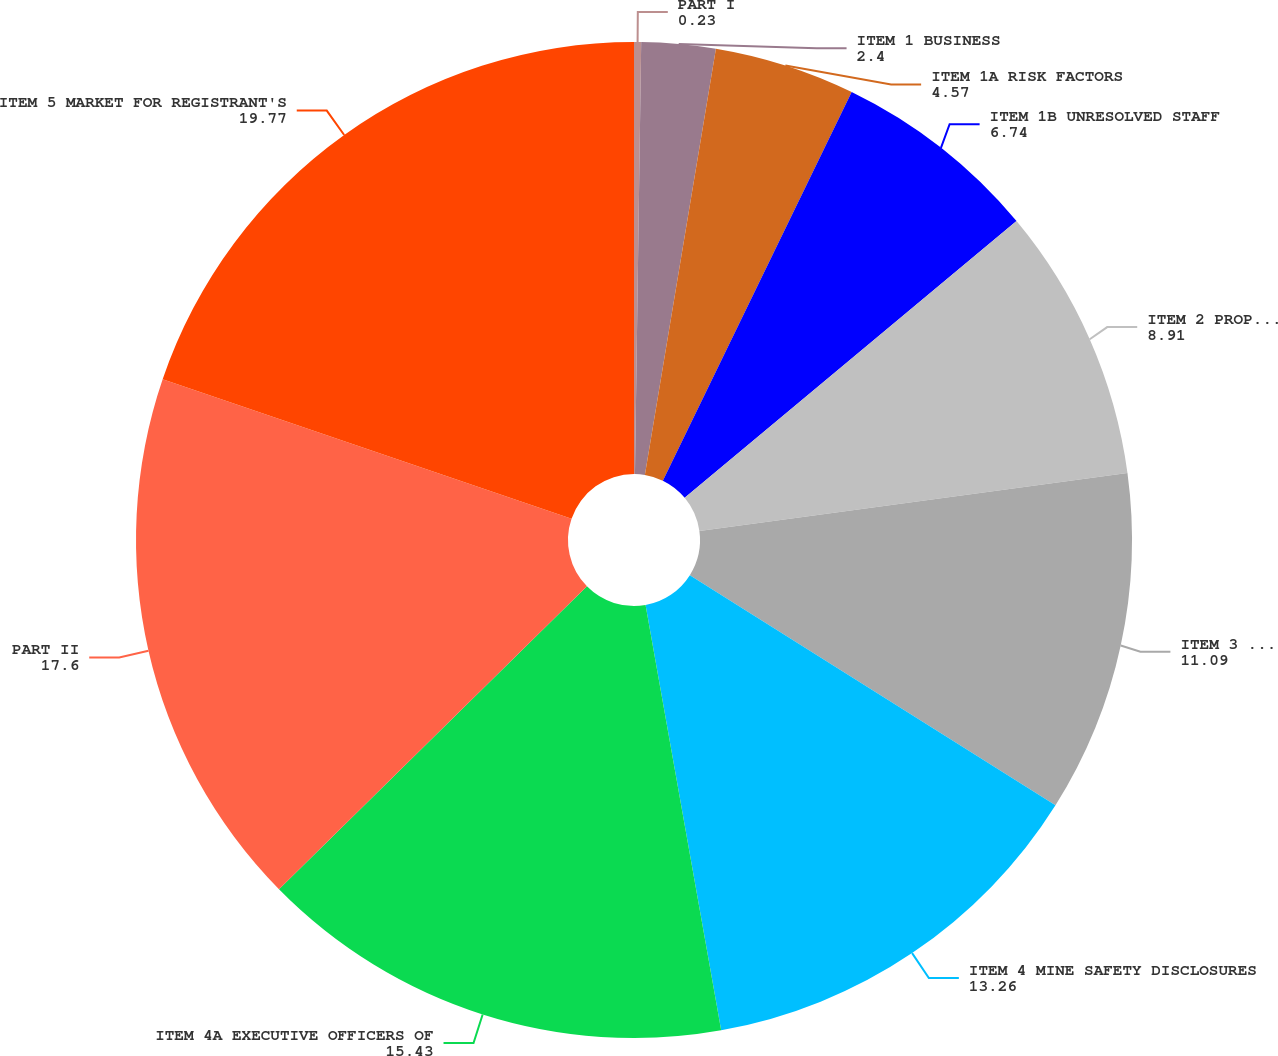Convert chart to OTSL. <chart><loc_0><loc_0><loc_500><loc_500><pie_chart><fcel>PART I<fcel>ITEM 1 BUSINESS<fcel>ITEM 1A RISK FACTORS<fcel>ITEM 1B UNRESOLVED STAFF<fcel>ITEM 2 PROPERTIES<fcel>ITEM 3 LEGAL PROCEEDINGS<fcel>ITEM 4 MINE SAFETY DISCLOSURES<fcel>ITEM 4A EXECUTIVE OFFICERS OF<fcel>PART II<fcel>ITEM 5 MARKET FOR REGISTRANT'S<nl><fcel>0.23%<fcel>2.4%<fcel>4.57%<fcel>6.74%<fcel>8.91%<fcel>11.09%<fcel>13.26%<fcel>15.43%<fcel>17.6%<fcel>19.77%<nl></chart> 